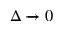Convert formula to latex. <formula><loc_0><loc_0><loc_500><loc_500>\Delta 0</formula> 